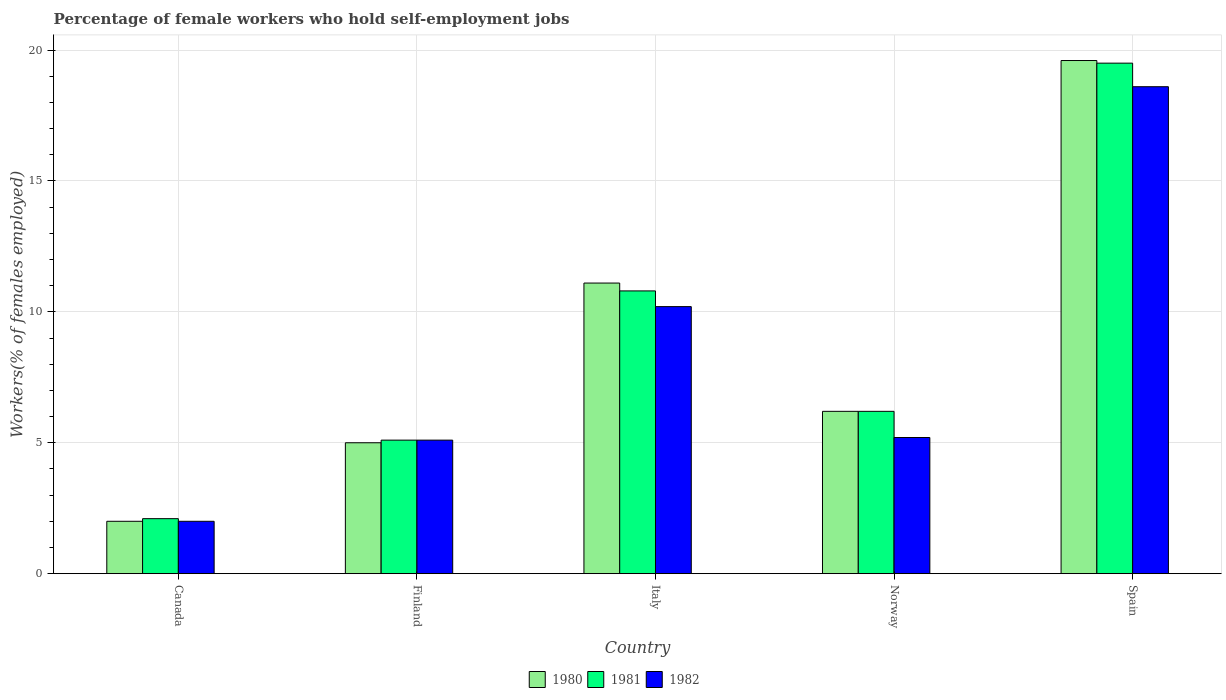How many different coloured bars are there?
Give a very brief answer. 3. How many groups of bars are there?
Offer a very short reply. 5. Are the number of bars per tick equal to the number of legend labels?
Offer a very short reply. Yes. Are the number of bars on each tick of the X-axis equal?
Your answer should be very brief. Yes. What is the label of the 2nd group of bars from the left?
Provide a short and direct response. Finland. In how many cases, is the number of bars for a given country not equal to the number of legend labels?
Make the answer very short. 0. What is the percentage of self-employed female workers in 1981 in Italy?
Provide a succinct answer. 10.8. Across all countries, what is the minimum percentage of self-employed female workers in 1981?
Ensure brevity in your answer.  2.1. In which country was the percentage of self-employed female workers in 1982 minimum?
Make the answer very short. Canada. What is the total percentage of self-employed female workers in 1982 in the graph?
Your response must be concise. 41.1. What is the difference between the percentage of self-employed female workers in 1981 in Finland and that in Spain?
Offer a terse response. -14.4. What is the difference between the percentage of self-employed female workers in 1980 in Spain and the percentage of self-employed female workers in 1982 in Italy?
Provide a short and direct response. 9.4. What is the average percentage of self-employed female workers in 1980 per country?
Give a very brief answer. 8.78. What is the difference between the percentage of self-employed female workers of/in 1982 and percentage of self-employed female workers of/in 1980 in Finland?
Ensure brevity in your answer.  0.1. In how many countries, is the percentage of self-employed female workers in 1982 greater than 10 %?
Keep it short and to the point. 2. What is the ratio of the percentage of self-employed female workers in 1982 in Finland to that in Norway?
Provide a succinct answer. 0.98. What is the difference between the highest and the second highest percentage of self-employed female workers in 1981?
Ensure brevity in your answer.  -8.7. What is the difference between the highest and the lowest percentage of self-employed female workers in 1981?
Give a very brief answer. 17.4. What does the 2nd bar from the right in Finland represents?
Your response must be concise. 1981. Is it the case that in every country, the sum of the percentage of self-employed female workers in 1982 and percentage of self-employed female workers in 1980 is greater than the percentage of self-employed female workers in 1981?
Your answer should be compact. Yes. How many countries are there in the graph?
Provide a short and direct response. 5. Are the values on the major ticks of Y-axis written in scientific E-notation?
Make the answer very short. No. Does the graph contain any zero values?
Your response must be concise. No. Does the graph contain grids?
Keep it short and to the point. Yes. Where does the legend appear in the graph?
Your response must be concise. Bottom center. What is the title of the graph?
Make the answer very short. Percentage of female workers who hold self-employment jobs. What is the label or title of the Y-axis?
Provide a succinct answer. Workers(% of females employed). What is the Workers(% of females employed) of 1981 in Canada?
Keep it short and to the point. 2.1. What is the Workers(% of females employed) of 1982 in Canada?
Your response must be concise. 2. What is the Workers(% of females employed) in 1980 in Finland?
Make the answer very short. 5. What is the Workers(% of females employed) of 1981 in Finland?
Your answer should be very brief. 5.1. What is the Workers(% of females employed) of 1982 in Finland?
Your response must be concise. 5.1. What is the Workers(% of females employed) in 1980 in Italy?
Your response must be concise. 11.1. What is the Workers(% of females employed) in 1981 in Italy?
Give a very brief answer. 10.8. What is the Workers(% of females employed) of 1982 in Italy?
Make the answer very short. 10.2. What is the Workers(% of females employed) of 1980 in Norway?
Offer a terse response. 6.2. What is the Workers(% of females employed) of 1981 in Norway?
Ensure brevity in your answer.  6.2. What is the Workers(% of females employed) of 1982 in Norway?
Offer a terse response. 5.2. What is the Workers(% of females employed) of 1980 in Spain?
Make the answer very short. 19.6. What is the Workers(% of females employed) of 1981 in Spain?
Make the answer very short. 19.5. What is the Workers(% of females employed) of 1982 in Spain?
Give a very brief answer. 18.6. Across all countries, what is the maximum Workers(% of females employed) in 1980?
Ensure brevity in your answer.  19.6. Across all countries, what is the maximum Workers(% of females employed) in 1982?
Offer a terse response. 18.6. Across all countries, what is the minimum Workers(% of females employed) in 1981?
Give a very brief answer. 2.1. Across all countries, what is the minimum Workers(% of females employed) of 1982?
Make the answer very short. 2. What is the total Workers(% of females employed) of 1980 in the graph?
Provide a succinct answer. 43.9. What is the total Workers(% of females employed) in 1981 in the graph?
Offer a terse response. 43.7. What is the total Workers(% of females employed) in 1982 in the graph?
Your answer should be very brief. 41.1. What is the difference between the Workers(% of females employed) in 1980 in Canada and that in Finland?
Offer a very short reply. -3. What is the difference between the Workers(% of females employed) of 1982 in Canada and that in Finland?
Give a very brief answer. -3.1. What is the difference between the Workers(% of females employed) of 1981 in Canada and that in Italy?
Your answer should be very brief. -8.7. What is the difference between the Workers(% of females employed) of 1982 in Canada and that in Italy?
Provide a succinct answer. -8.2. What is the difference between the Workers(% of females employed) of 1980 in Canada and that in Norway?
Your answer should be compact. -4.2. What is the difference between the Workers(% of females employed) in 1981 in Canada and that in Norway?
Your answer should be very brief. -4.1. What is the difference between the Workers(% of females employed) of 1980 in Canada and that in Spain?
Provide a succinct answer. -17.6. What is the difference between the Workers(% of females employed) of 1981 in Canada and that in Spain?
Offer a terse response. -17.4. What is the difference between the Workers(% of females employed) of 1982 in Canada and that in Spain?
Provide a short and direct response. -16.6. What is the difference between the Workers(% of females employed) in 1982 in Finland and that in Italy?
Give a very brief answer. -5.1. What is the difference between the Workers(% of females employed) of 1980 in Finland and that in Spain?
Your answer should be compact. -14.6. What is the difference between the Workers(% of females employed) in 1981 in Finland and that in Spain?
Your answer should be very brief. -14.4. What is the difference between the Workers(% of females employed) in 1981 in Italy and that in Norway?
Offer a very short reply. 4.6. What is the difference between the Workers(% of females employed) in 1982 in Italy and that in Spain?
Make the answer very short. -8.4. What is the difference between the Workers(% of females employed) in 1981 in Norway and that in Spain?
Give a very brief answer. -13.3. What is the difference between the Workers(% of females employed) in 1982 in Norway and that in Spain?
Your response must be concise. -13.4. What is the difference between the Workers(% of females employed) in 1981 in Canada and the Workers(% of females employed) in 1982 in Finland?
Keep it short and to the point. -3. What is the difference between the Workers(% of females employed) in 1980 in Canada and the Workers(% of females employed) in 1981 in Norway?
Provide a succinct answer. -4.2. What is the difference between the Workers(% of females employed) of 1980 in Canada and the Workers(% of females employed) of 1981 in Spain?
Provide a short and direct response. -17.5. What is the difference between the Workers(% of females employed) of 1980 in Canada and the Workers(% of females employed) of 1982 in Spain?
Give a very brief answer. -16.6. What is the difference between the Workers(% of females employed) of 1981 in Canada and the Workers(% of females employed) of 1982 in Spain?
Offer a terse response. -16.5. What is the difference between the Workers(% of females employed) in 1980 in Finland and the Workers(% of females employed) in 1981 in Norway?
Offer a terse response. -1.2. What is the difference between the Workers(% of females employed) of 1980 in Finland and the Workers(% of females employed) of 1982 in Norway?
Offer a very short reply. -0.2. What is the difference between the Workers(% of females employed) of 1981 in Finland and the Workers(% of females employed) of 1982 in Norway?
Offer a very short reply. -0.1. What is the difference between the Workers(% of females employed) in 1980 in Italy and the Workers(% of females employed) in 1982 in Norway?
Your answer should be very brief. 5.9. What is the difference between the Workers(% of females employed) in 1981 in Italy and the Workers(% of females employed) in 1982 in Norway?
Offer a very short reply. 5.6. What is the difference between the Workers(% of females employed) of 1980 in Italy and the Workers(% of females employed) of 1981 in Spain?
Give a very brief answer. -8.4. What is the difference between the Workers(% of females employed) in 1981 in Norway and the Workers(% of females employed) in 1982 in Spain?
Your response must be concise. -12.4. What is the average Workers(% of females employed) in 1980 per country?
Give a very brief answer. 8.78. What is the average Workers(% of females employed) in 1981 per country?
Keep it short and to the point. 8.74. What is the average Workers(% of females employed) of 1982 per country?
Make the answer very short. 8.22. What is the difference between the Workers(% of females employed) in 1980 and Workers(% of females employed) in 1981 in Canada?
Your answer should be very brief. -0.1. What is the difference between the Workers(% of females employed) in 1980 and Workers(% of females employed) in 1981 in Finland?
Offer a very short reply. -0.1. What is the difference between the Workers(% of females employed) of 1980 and Workers(% of females employed) of 1982 in Finland?
Keep it short and to the point. -0.1. What is the difference between the Workers(% of females employed) in 1980 and Workers(% of females employed) in 1981 in Italy?
Offer a terse response. 0.3. What is the difference between the Workers(% of females employed) of 1980 and Workers(% of females employed) of 1982 in Italy?
Provide a short and direct response. 0.9. What is the difference between the Workers(% of females employed) of 1981 and Workers(% of females employed) of 1982 in Italy?
Provide a succinct answer. 0.6. What is the difference between the Workers(% of females employed) of 1980 and Workers(% of females employed) of 1982 in Norway?
Provide a succinct answer. 1. What is the difference between the Workers(% of females employed) of 1981 and Workers(% of females employed) of 1982 in Norway?
Provide a succinct answer. 1. What is the difference between the Workers(% of females employed) of 1980 and Workers(% of females employed) of 1981 in Spain?
Give a very brief answer. 0.1. What is the difference between the Workers(% of females employed) of 1980 and Workers(% of females employed) of 1982 in Spain?
Provide a succinct answer. 1. What is the difference between the Workers(% of females employed) of 1981 and Workers(% of females employed) of 1982 in Spain?
Provide a short and direct response. 0.9. What is the ratio of the Workers(% of females employed) of 1980 in Canada to that in Finland?
Make the answer very short. 0.4. What is the ratio of the Workers(% of females employed) in 1981 in Canada to that in Finland?
Your response must be concise. 0.41. What is the ratio of the Workers(% of females employed) of 1982 in Canada to that in Finland?
Your answer should be very brief. 0.39. What is the ratio of the Workers(% of females employed) in 1980 in Canada to that in Italy?
Make the answer very short. 0.18. What is the ratio of the Workers(% of females employed) in 1981 in Canada to that in Italy?
Your response must be concise. 0.19. What is the ratio of the Workers(% of females employed) of 1982 in Canada to that in Italy?
Provide a succinct answer. 0.2. What is the ratio of the Workers(% of females employed) of 1980 in Canada to that in Norway?
Offer a terse response. 0.32. What is the ratio of the Workers(% of females employed) in 1981 in Canada to that in Norway?
Your answer should be compact. 0.34. What is the ratio of the Workers(% of females employed) of 1982 in Canada to that in Norway?
Your answer should be very brief. 0.38. What is the ratio of the Workers(% of females employed) in 1980 in Canada to that in Spain?
Offer a very short reply. 0.1. What is the ratio of the Workers(% of females employed) in 1981 in Canada to that in Spain?
Make the answer very short. 0.11. What is the ratio of the Workers(% of females employed) of 1982 in Canada to that in Spain?
Your response must be concise. 0.11. What is the ratio of the Workers(% of females employed) of 1980 in Finland to that in Italy?
Offer a very short reply. 0.45. What is the ratio of the Workers(% of females employed) in 1981 in Finland to that in Italy?
Ensure brevity in your answer.  0.47. What is the ratio of the Workers(% of females employed) in 1980 in Finland to that in Norway?
Provide a short and direct response. 0.81. What is the ratio of the Workers(% of females employed) in 1981 in Finland to that in Norway?
Keep it short and to the point. 0.82. What is the ratio of the Workers(% of females employed) of 1982 in Finland to that in Norway?
Provide a short and direct response. 0.98. What is the ratio of the Workers(% of females employed) in 1980 in Finland to that in Spain?
Give a very brief answer. 0.26. What is the ratio of the Workers(% of females employed) of 1981 in Finland to that in Spain?
Make the answer very short. 0.26. What is the ratio of the Workers(% of females employed) of 1982 in Finland to that in Spain?
Ensure brevity in your answer.  0.27. What is the ratio of the Workers(% of females employed) of 1980 in Italy to that in Norway?
Keep it short and to the point. 1.79. What is the ratio of the Workers(% of females employed) in 1981 in Italy to that in Norway?
Your answer should be compact. 1.74. What is the ratio of the Workers(% of females employed) in 1982 in Italy to that in Norway?
Give a very brief answer. 1.96. What is the ratio of the Workers(% of females employed) in 1980 in Italy to that in Spain?
Offer a very short reply. 0.57. What is the ratio of the Workers(% of females employed) of 1981 in Italy to that in Spain?
Keep it short and to the point. 0.55. What is the ratio of the Workers(% of females employed) of 1982 in Italy to that in Spain?
Provide a short and direct response. 0.55. What is the ratio of the Workers(% of females employed) in 1980 in Norway to that in Spain?
Offer a terse response. 0.32. What is the ratio of the Workers(% of females employed) of 1981 in Norway to that in Spain?
Keep it short and to the point. 0.32. What is the ratio of the Workers(% of females employed) in 1982 in Norway to that in Spain?
Provide a succinct answer. 0.28. What is the difference between the highest and the second highest Workers(% of females employed) in 1980?
Make the answer very short. 8.5. What is the difference between the highest and the second highest Workers(% of females employed) in 1981?
Provide a succinct answer. 8.7. What is the difference between the highest and the lowest Workers(% of females employed) in 1981?
Give a very brief answer. 17.4. 